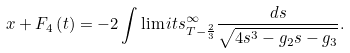Convert formula to latex. <formula><loc_0><loc_0><loc_500><loc_500>x + F _ { 4 } \left ( { t } \right ) = - 2 \int \lim i t s _ { T - \frac { 2 } { 3 } } ^ { \infty } { \frac { d s } { { \sqrt { 4 s ^ { 3 } - g _ { 2 } s - g _ { 3 } } } } } .</formula> 